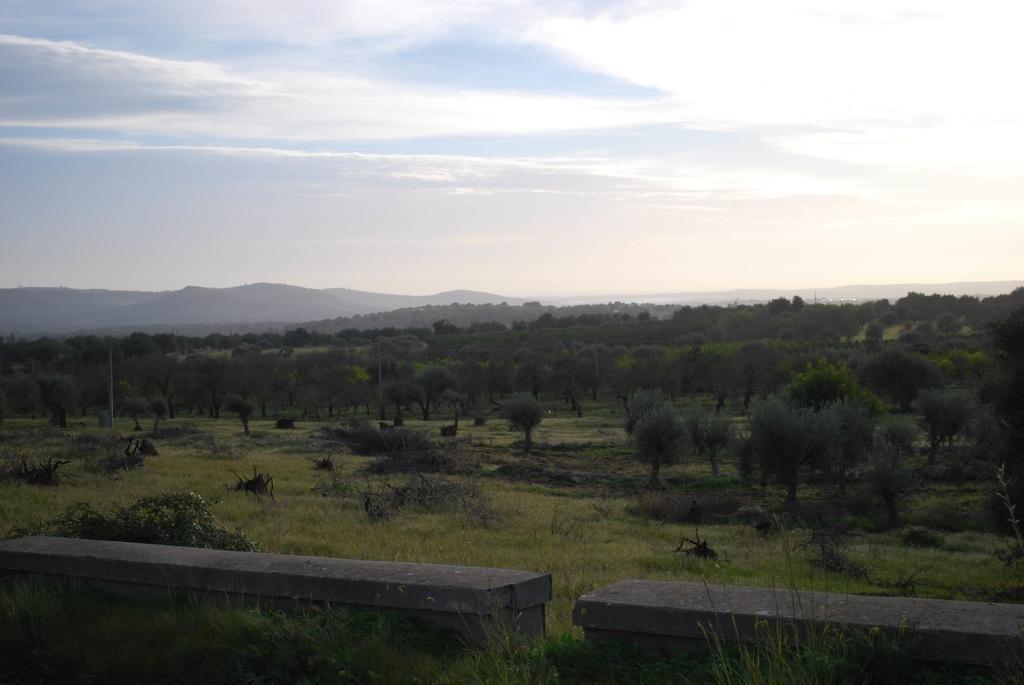Please provide a concise description of this image. In the image there is a greenery and in the front there are two cement benches, in the background there are mountains. 